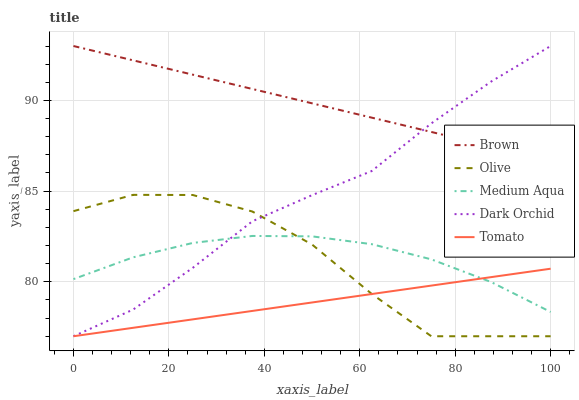Does Tomato have the minimum area under the curve?
Answer yes or no. Yes. Does Brown have the maximum area under the curve?
Answer yes or no. Yes. Does Brown have the minimum area under the curve?
Answer yes or no. No. Does Tomato have the maximum area under the curve?
Answer yes or no. No. Is Tomato the smoothest?
Answer yes or no. Yes. Is Olive the roughest?
Answer yes or no. Yes. Is Brown the smoothest?
Answer yes or no. No. Is Brown the roughest?
Answer yes or no. No. Does Olive have the lowest value?
Answer yes or no. Yes. Does Brown have the lowest value?
Answer yes or no. No. Does Dark Orchid have the highest value?
Answer yes or no. Yes. Does Tomato have the highest value?
Answer yes or no. No. Is Olive less than Brown?
Answer yes or no. Yes. Is Brown greater than Olive?
Answer yes or no. Yes. Does Tomato intersect Olive?
Answer yes or no. Yes. Is Tomato less than Olive?
Answer yes or no. No. Is Tomato greater than Olive?
Answer yes or no. No. Does Olive intersect Brown?
Answer yes or no. No. 